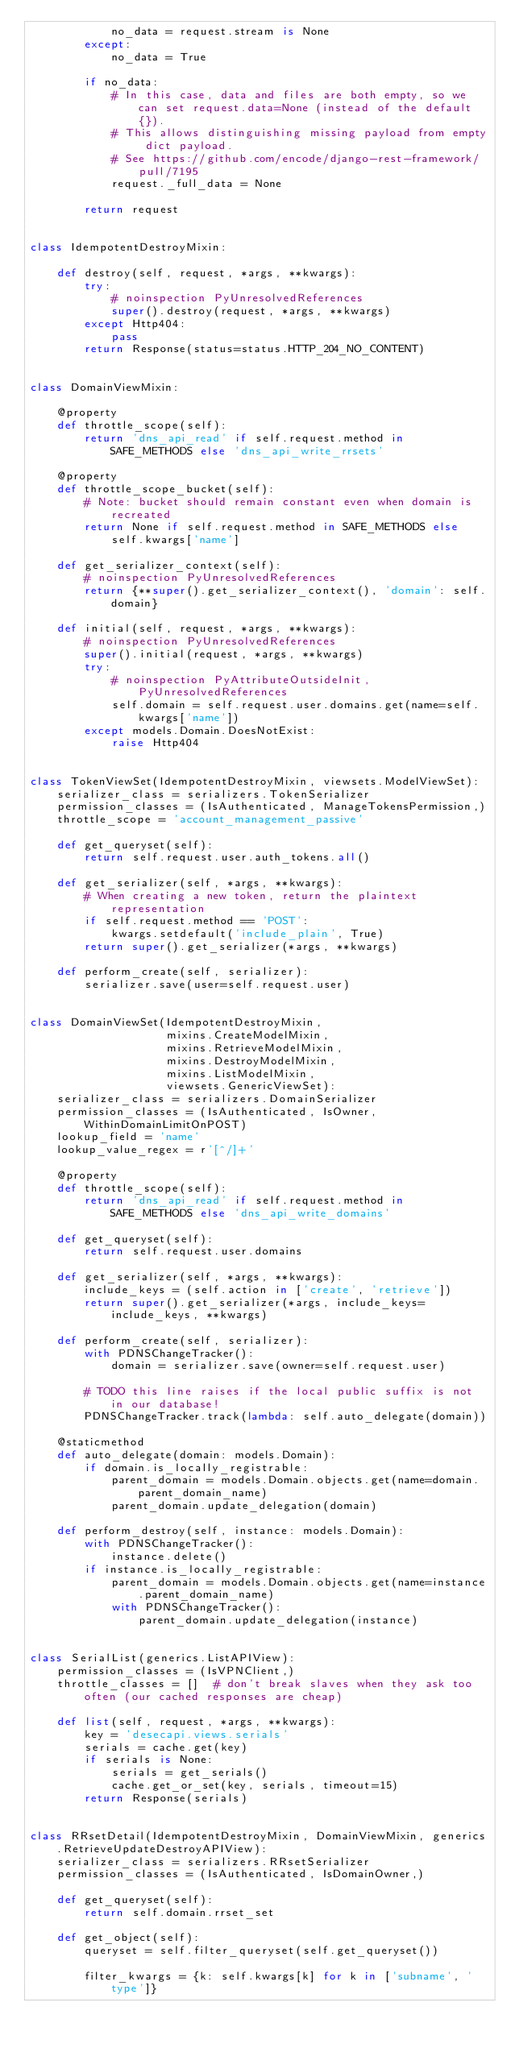Convert code to text. <code><loc_0><loc_0><loc_500><loc_500><_Python_>            no_data = request.stream is None
        except:
            no_data = True

        if no_data:
            # In this case, data and files are both empty, so we can set request.data=None (instead of the default {}).
            # This allows distinguishing missing payload from empty dict payload.
            # See https://github.com/encode/django-rest-framework/pull/7195
            request._full_data = None

        return request


class IdempotentDestroyMixin:

    def destroy(self, request, *args, **kwargs):
        try:
            # noinspection PyUnresolvedReferences
            super().destroy(request, *args, **kwargs)
        except Http404:
            pass
        return Response(status=status.HTTP_204_NO_CONTENT)


class DomainViewMixin:

    @property
    def throttle_scope(self):
        return 'dns_api_read' if self.request.method in SAFE_METHODS else 'dns_api_write_rrsets'

    @property
    def throttle_scope_bucket(self):
        # Note: bucket should remain constant even when domain is recreated
        return None if self.request.method in SAFE_METHODS else self.kwargs['name']

    def get_serializer_context(self):
        # noinspection PyUnresolvedReferences
        return {**super().get_serializer_context(), 'domain': self.domain}

    def initial(self, request, *args, **kwargs):
        # noinspection PyUnresolvedReferences
        super().initial(request, *args, **kwargs)
        try:
            # noinspection PyAttributeOutsideInit, PyUnresolvedReferences
            self.domain = self.request.user.domains.get(name=self.kwargs['name'])
        except models.Domain.DoesNotExist:
            raise Http404


class TokenViewSet(IdempotentDestroyMixin, viewsets.ModelViewSet):
    serializer_class = serializers.TokenSerializer
    permission_classes = (IsAuthenticated, ManageTokensPermission,)
    throttle_scope = 'account_management_passive'

    def get_queryset(self):
        return self.request.user.auth_tokens.all()

    def get_serializer(self, *args, **kwargs):
        # When creating a new token, return the plaintext representation
        if self.request.method == 'POST':
            kwargs.setdefault('include_plain', True)
        return super().get_serializer(*args, **kwargs)

    def perform_create(self, serializer):
        serializer.save(user=self.request.user)


class DomainViewSet(IdempotentDestroyMixin,
                    mixins.CreateModelMixin,
                    mixins.RetrieveModelMixin,
                    mixins.DestroyModelMixin,
                    mixins.ListModelMixin,
                    viewsets.GenericViewSet):
    serializer_class = serializers.DomainSerializer
    permission_classes = (IsAuthenticated, IsOwner, WithinDomainLimitOnPOST)
    lookup_field = 'name'
    lookup_value_regex = r'[^/]+'

    @property
    def throttle_scope(self):
        return 'dns_api_read' if self.request.method in SAFE_METHODS else 'dns_api_write_domains'

    def get_queryset(self):
        return self.request.user.domains

    def get_serializer(self, *args, **kwargs):
        include_keys = (self.action in ['create', 'retrieve'])
        return super().get_serializer(*args, include_keys=include_keys, **kwargs)

    def perform_create(self, serializer):
        with PDNSChangeTracker():
            domain = serializer.save(owner=self.request.user)

        # TODO this line raises if the local public suffix is not in our database!
        PDNSChangeTracker.track(lambda: self.auto_delegate(domain))

    @staticmethod
    def auto_delegate(domain: models.Domain):
        if domain.is_locally_registrable:
            parent_domain = models.Domain.objects.get(name=domain.parent_domain_name)
            parent_domain.update_delegation(domain)

    def perform_destroy(self, instance: models.Domain):
        with PDNSChangeTracker():
            instance.delete()
        if instance.is_locally_registrable:
            parent_domain = models.Domain.objects.get(name=instance.parent_domain_name)
            with PDNSChangeTracker():
                parent_domain.update_delegation(instance)


class SerialList(generics.ListAPIView):
    permission_classes = (IsVPNClient,)
    throttle_classes = []  # don't break slaves when they ask too often (our cached responses are cheap)

    def list(self, request, *args, **kwargs):
        key = 'desecapi.views.serials'
        serials = cache.get(key)
        if serials is None:
            serials = get_serials()
            cache.get_or_set(key, serials, timeout=15)
        return Response(serials)


class RRsetDetail(IdempotentDestroyMixin, DomainViewMixin, generics.RetrieveUpdateDestroyAPIView):
    serializer_class = serializers.RRsetSerializer
    permission_classes = (IsAuthenticated, IsDomainOwner,)

    def get_queryset(self):
        return self.domain.rrset_set

    def get_object(self):
        queryset = self.filter_queryset(self.get_queryset())

        filter_kwargs = {k: self.kwargs[k] for k in ['subname', 'type']}</code> 